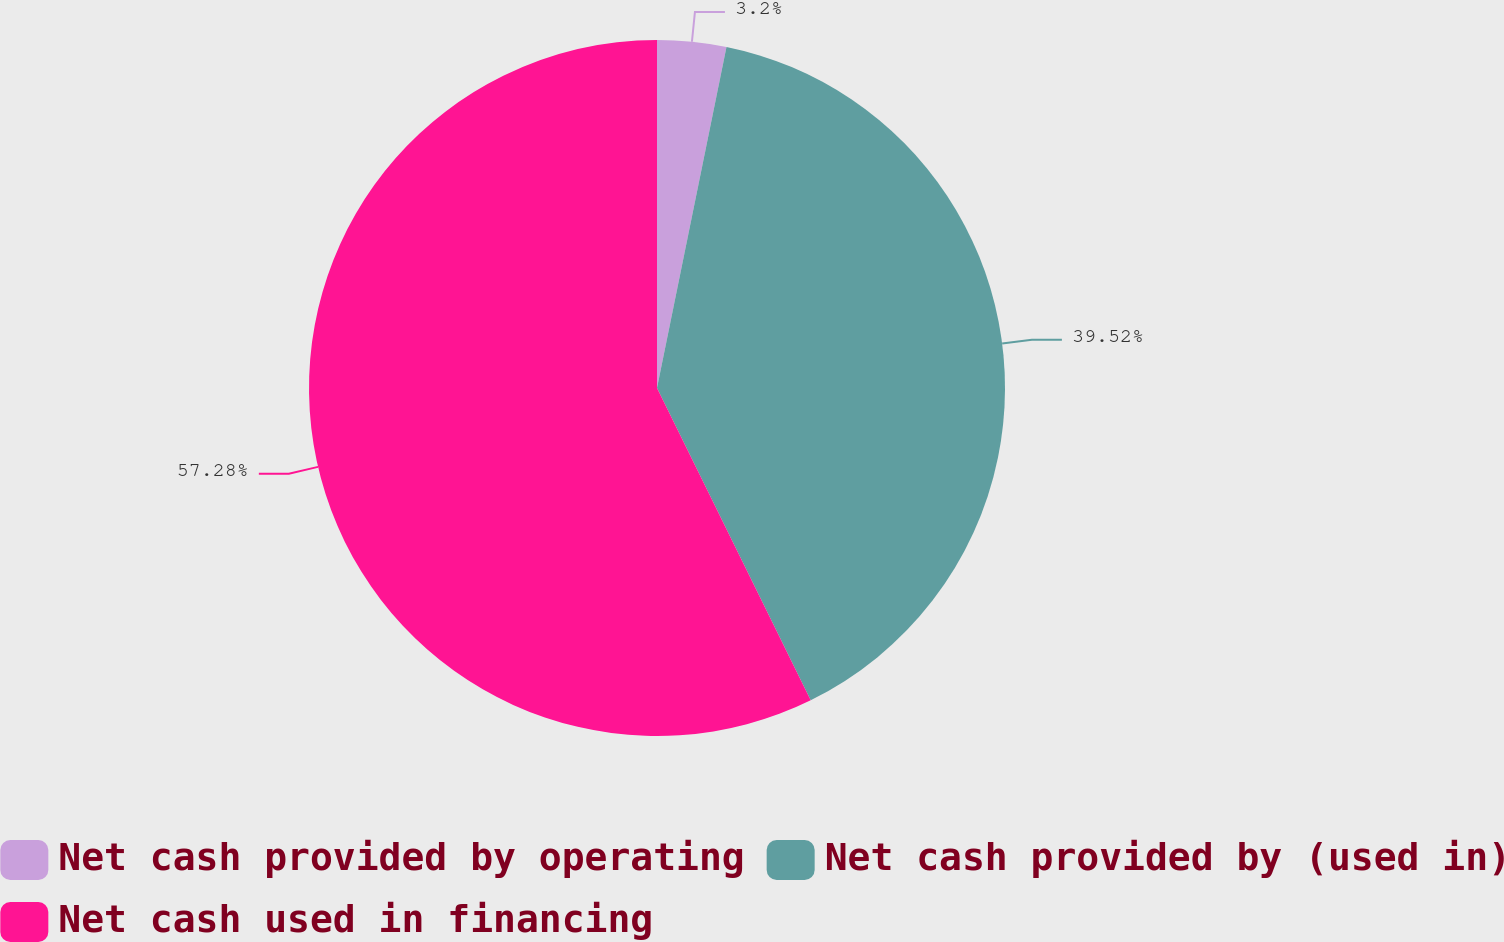Convert chart to OTSL. <chart><loc_0><loc_0><loc_500><loc_500><pie_chart><fcel>Net cash provided by operating<fcel>Net cash provided by (used in)<fcel>Net cash used in financing<nl><fcel>3.2%<fcel>39.52%<fcel>57.28%<nl></chart> 